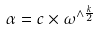Convert formula to latex. <formula><loc_0><loc_0><loc_500><loc_500>\alpha = c \times \omega ^ { \wedge \frac { k } { 2 } }</formula> 